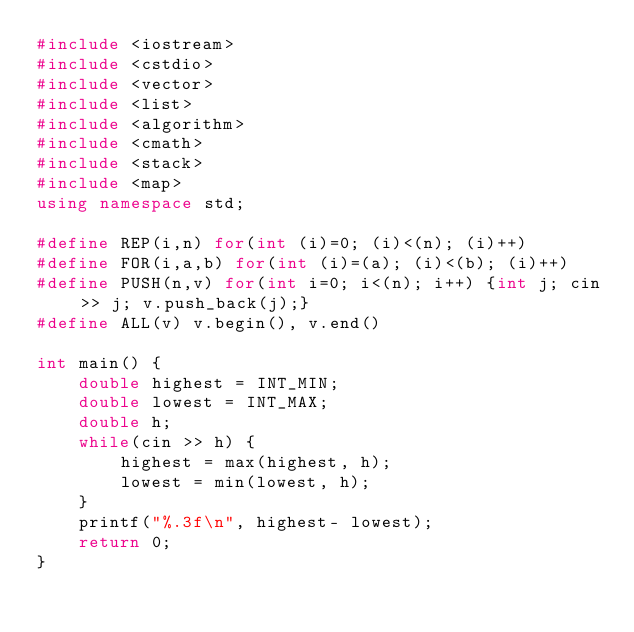Convert code to text. <code><loc_0><loc_0><loc_500><loc_500><_C++_>#include <iostream>
#include <cstdio>
#include <vector>
#include <list>
#include <algorithm>
#include <cmath>
#include <stack>
#include <map>
using namespace std;

#define REP(i,n) for(int (i)=0; (i)<(n); (i)++)
#define FOR(i,a,b) for(int (i)=(a); (i)<(b); (i)++)
#define PUSH(n,v) for(int i=0; i<(n); i++) {int j; cin >> j; v.push_back(j);}
#define ALL(v) v.begin(), v.end()

int main() {
    double highest = INT_MIN;
    double lowest = INT_MAX;
    double h;
    while(cin >> h) {
        highest = max(highest, h);
        lowest = min(lowest, h);
    }
    printf("%.3f\n", highest- lowest);
    return 0;
}</code> 